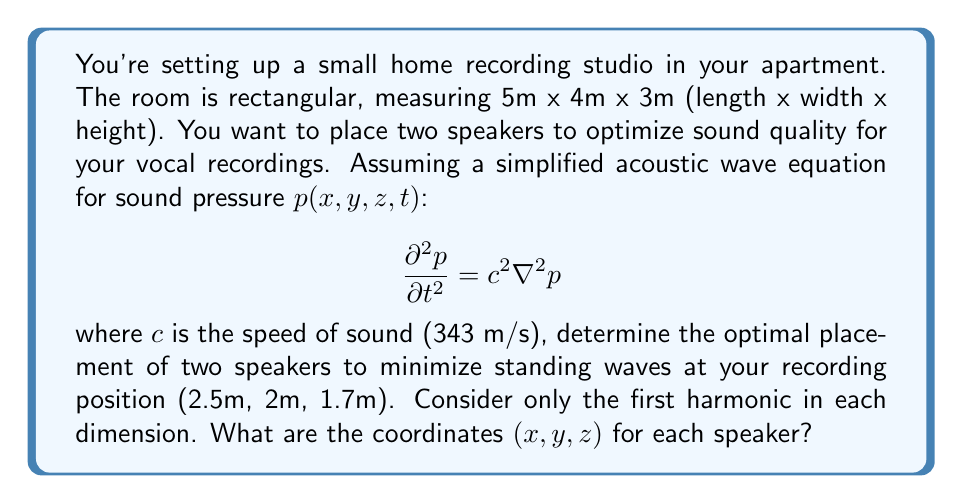Solve this math problem. Let's approach this step-by-step:

1) First, we need to find the room modes (standing waves) for each dimension. The frequencies of these modes are given by:

   $$f_{nx,ny,nz} = \frac{c}{2}\sqrt{(\frac{n_x}{L_x})^2 + (\frac{n_y}{L_y})^2 + (\frac{n_z}{L_z})^2}$$

   where $n_x$, $n_y$, and $n_z$ are integers, and $L_x$, $L_y$, and $L_z$ are the room dimensions.

2) For the first harmonic in each dimension (nx = ny = nz = 1):

   $$f_{1,1,1} = \frac{343}{2}\sqrt{(\frac{1}{5})^2 + (\frac{1}{4})^2 + (\frac{1}{3})^2} \approx 69.8 \text{ Hz}$$

3) The standing wave pattern for each dimension is given by:

   $$p_x(x) = A \cos(\frac{\pi x}{L_x})$$
   $$p_y(y) = B \cos(\frac{\pi y}{L_y})$$
   $$p_z(z) = C \cos(\frac{\pi z}{L_z})$$

4) To minimize standing waves, we want to place the speakers at the nodes of these standing waves. The nodes occur at:

   $$x = \frac{L_x}{2}, y = \frac{L_y}{2}, z = \frac{L_z}{2}$$

5) However, we can't place both speakers at the same point. We need to offset them slightly. A good practice is to place them symmetrically about the center of the room.

6) Let's offset the speakers by 0.5m in the x-direction and 0.25m in the y-direction from the center. The z-coordinate can remain at the midpoint.

7) Therefore, the optimal coordinates for the two speakers are:

   Speaker 1: $(2.0\text{m}, 1.75\text{m}, 1.5\text{m})$
   Speaker 2: $(3.0\text{m}, 2.25\text{m}, 1.5\text{m})$

These positions should help minimize standing waves at your recording position while maintaining stereo imaging.
Answer: Speaker 1: (2.0m, 1.75m, 1.5m), Speaker 2: (3.0m, 2.25m, 1.5m) 